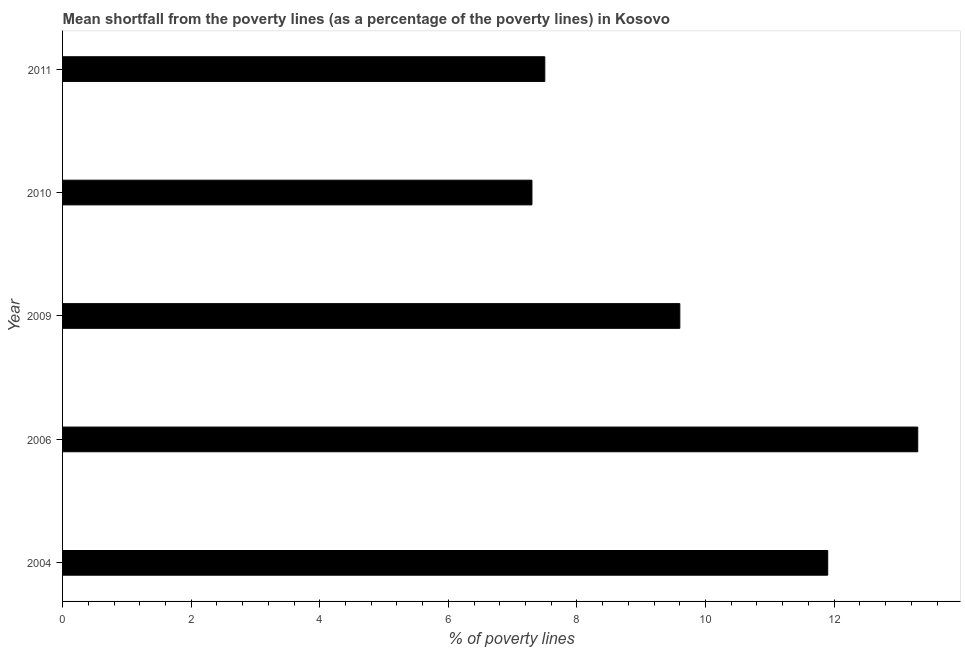Does the graph contain grids?
Keep it short and to the point. No. What is the title of the graph?
Your answer should be very brief. Mean shortfall from the poverty lines (as a percentage of the poverty lines) in Kosovo. What is the label or title of the X-axis?
Offer a very short reply. % of poverty lines. What is the label or title of the Y-axis?
Offer a terse response. Year. What is the poverty gap at national poverty lines in 2004?
Make the answer very short. 11.9. What is the sum of the poverty gap at national poverty lines?
Offer a very short reply. 49.6. What is the average poverty gap at national poverty lines per year?
Your answer should be compact. 9.92. In how many years, is the poverty gap at national poverty lines greater than 4.4 %?
Keep it short and to the point. 5. Do a majority of the years between 2009 and 2010 (inclusive) have poverty gap at national poverty lines greater than 12 %?
Keep it short and to the point. No. What is the ratio of the poverty gap at national poverty lines in 2004 to that in 2011?
Provide a succinct answer. 1.59. Is the poverty gap at national poverty lines in 2010 less than that in 2011?
Give a very brief answer. Yes. Is the difference between the poverty gap at national poverty lines in 2009 and 2011 greater than the difference between any two years?
Make the answer very short. No. What is the difference between the highest and the second highest poverty gap at national poverty lines?
Your response must be concise. 1.4. Is the sum of the poverty gap at national poverty lines in 2004 and 2009 greater than the maximum poverty gap at national poverty lines across all years?
Keep it short and to the point. Yes. How many bars are there?
Your answer should be very brief. 5. What is the difference between two consecutive major ticks on the X-axis?
Your answer should be compact. 2. What is the difference between the % of poverty lines in 2004 and 2006?
Ensure brevity in your answer.  -1.4. What is the difference between the % of poverty lines in 2004 and 2009?
Ensure brevity in your answer.  2.3. What is the difference between the % of poverty lines in 2004 and 2010?
Your response must be concise. 4.6. What is the difference between the % of poverty lines in 2004 and 2011?
Offer a very short reply. 4.4. What is the difference between the % of poverty lines in 2006 and 2010?
Keep it short and to the point. 6. What is the difference between the % of poverty lines in 2009 and 2011?
Your response must be concise. 2.1. What is the ratio of the % of poverty lines in 2004 to that in 2006?
Offer a terse response. 0.9. What is the ratio of the % of poverty lines in 2004 to that in 2009?
Offer a terse response. 1.24. What is the ratio of the % of poverty lines in 2004 to that in 2010?
Give a very brief answer. 1.63. What is the ratio of the % of poverty lines in 2004 to that in 2011?
Offer a very short reply. 1.59. What is the ratio of the % of poverty lines in 2006 to that in 2009?
Offer a terse response. 1.39. What is the ratio of the % of poverty lines in 2006 to that in 2010?
Keep it short and to the point. 1.82. What is the ratio of the % of poverty lines in 2006 to that in 2011?
Keep it short and to the point. 1.77. What is the ratio of the % of poverty lines in 2009 to that in 2010?
Offer a very short reply. 1.31. What is the ratio of the % of poverty lines in 2009 to that in 2011?
Your answer should be very brief. 1.28. 